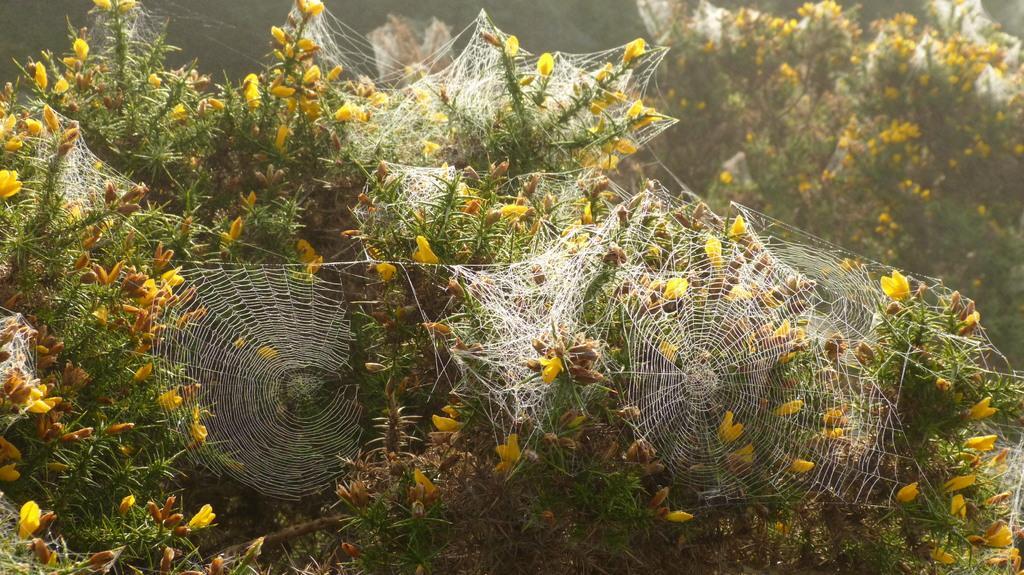Please provide a concise description of this image. In this image we can see spider nets on the plants. 